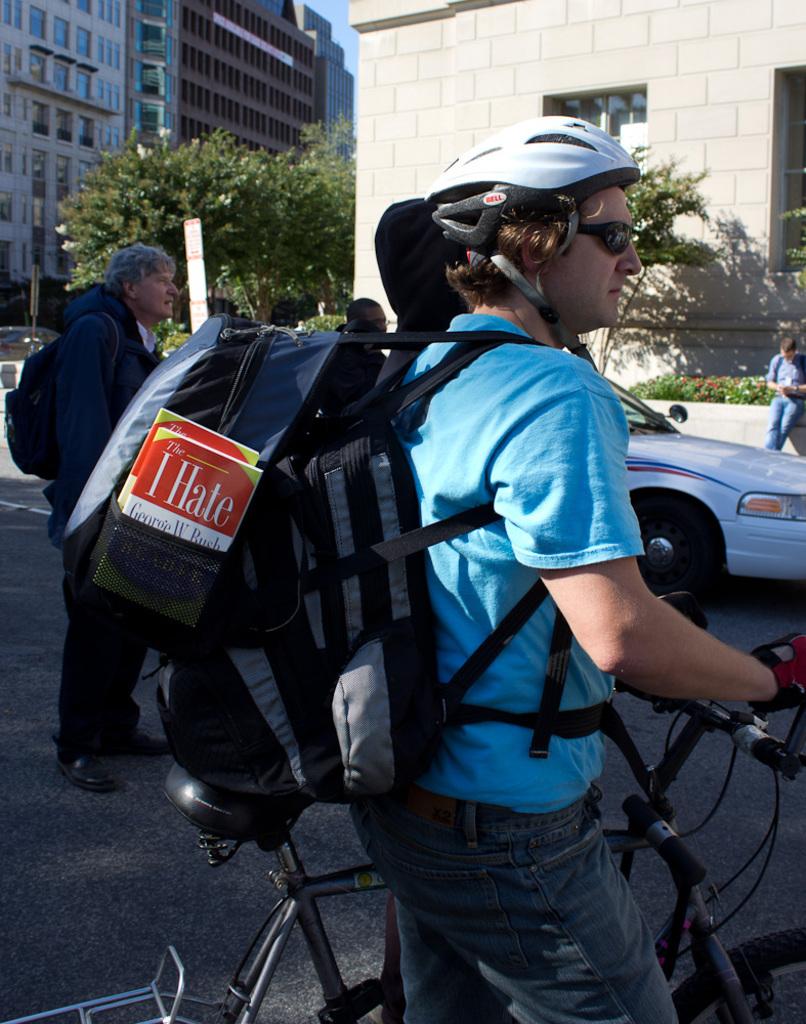What is the word on the backpack?
Provide a short and direct response. I hate. What is the brand of the helmet?
Provide a short and direct response. Bell. 